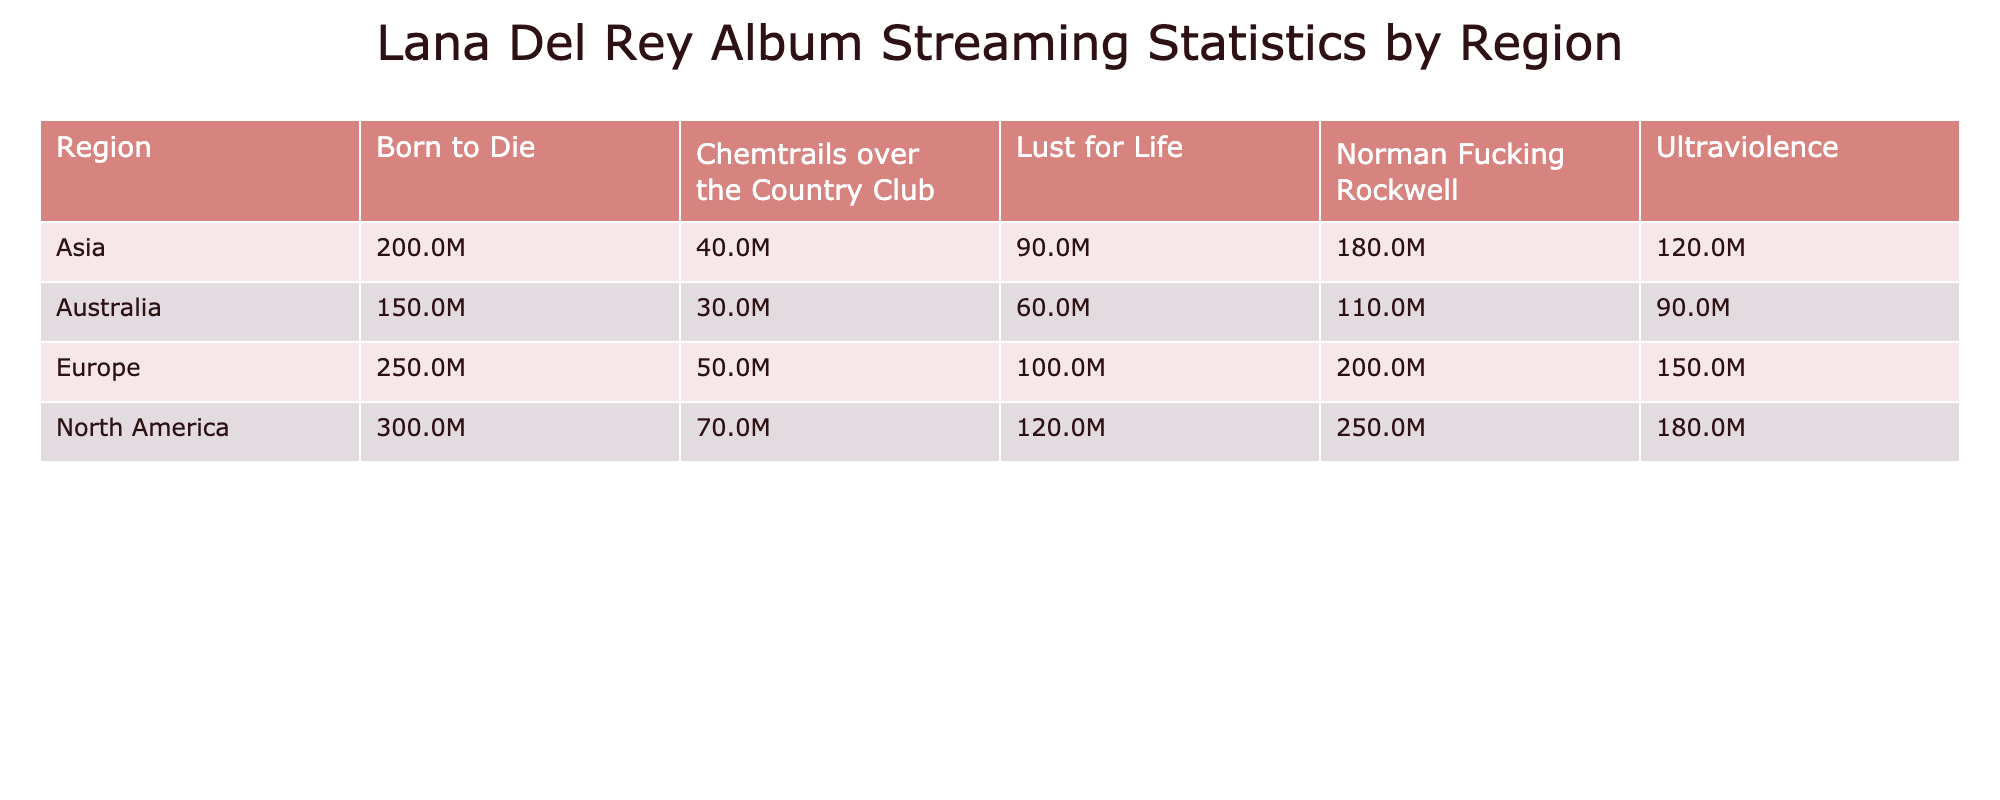What is the streaming count of "Norman Fucking Rockwell" in North America? From the table, we look under the North America column for the album "Norman Fucking Rockwell". It shows a streaming count of 250,000,000.
Answer: 250,000,000 Which album has the highest streaming count in Europe? In the Europe section of the table, we can see that "Born to Die" has the highest streaming count at 250,000,000.
Answer: Born to Die How many streaming counts does "Chemtrails over the Country Club" have compared to "Lust for Life" in Asia? Under the Asia section, "Chemtrails over the Country Club" has a streaming count of 40,000,000, while "Lust for Life" has 90,000,000. To compare, we can find the difference: 90,000,000 - 40,000,000 = 50,000,000.
Answer: 50,000,000 Is the streaming count for "Ultraviolence" in North America greater than in Australia? In North America, "Ultraviolence" has 180,000,000 streams, and in Australia, it has 90,000,000. Since 180,000,000 is greater than 90,000,000, the statement is true.
Answer: Yes What is the total streaming count for "Born to Die" across all regions? We sum the streaming counts for "Born to Die" from all regions: North America (300,000,000) + Europe (250,000,000) + Asia (200,000,000) + Australia (150,000,000) = 900,000,000.
Answer: 900,000,000 Which region has the lowest streaming count for "Chemtrails over the Country Club"? Looking at the table, Australia has the lowest streaming count at 30,000,000 compared to North America (70,000,000), Europe (50,000,000), and Asia (40,000,000).
Answer: Australia Which album's streaming count in North America is closest to its streaming count in Europe? We look at the streaming counts: "Born to Die" (300M vs 250M), "Ultraviolence" (180M vs 150M), "Lust for Life" (120M vs 100M), "Norman Fucking Rockwell" (250M vs 200M), and "Chemtrails over the Country Club" (70M vs 50M). The closest is "Ultraviolence" with a difference of 30,000,000.
Answer: Ultraviolence What is the average streaming count for "Lust for Life" across all regions? We add the streaming counts: North America (120,000,000) + Europe (100,000,000) + Asia (90,000,000) + Australia (60,000,000) = 370,000,000. We then divide by the number of regions which is 4: 370,000,000 / 4 = 92,500,000.
Answer: 92,500,000 Does "Lust for Life" have a higher streaming count in North America than in Australia? In North America, "Lust for Life" has 120,000,000 streams, and in Australia, it has 60,000,000. Since 120,000,000 is greater than 60,000,000, the statement is true.
Answer: Yes 